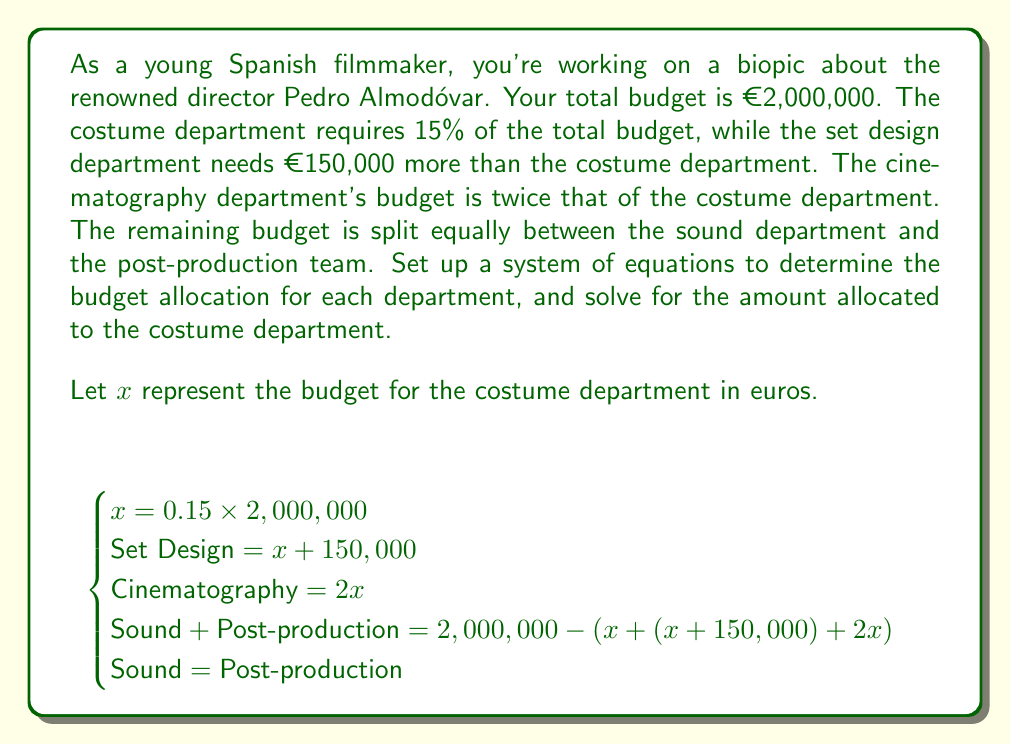Can you answer this question? Let's solve this system of equations step by step:

1) From the first equation:
   $x = 0.15 \times 2,000,000 = 300,000$

2) Now we can calculate the budget for each department:
   - Costume: $x = 300,000$
   - Set Design: $x + 150,000 = 300,000 + 150,000 = 450,000$
   - Cinematography: $2x = 2 \times 300,000 = 600,000$

3) The remaining budget for Sound and Post-production:
   $2,000,000 - (300,000 + 450,000 + 600,000) = 650,000$

4) Since Sound and Post-production split the remaining budget equally:
   Sound = Post-production = $650,000 \div 2 = 325,000$

5) Let's verify that all budgets sum up to the total:
   $300,000 + 450,000 + 600,000 + 325,000 + 325,000 = 2,000,000$

Therefore, the system of equations is solved, and we have found the budget allocation for each department.
Answer: The budget allocated to the costume department is €300,000. 